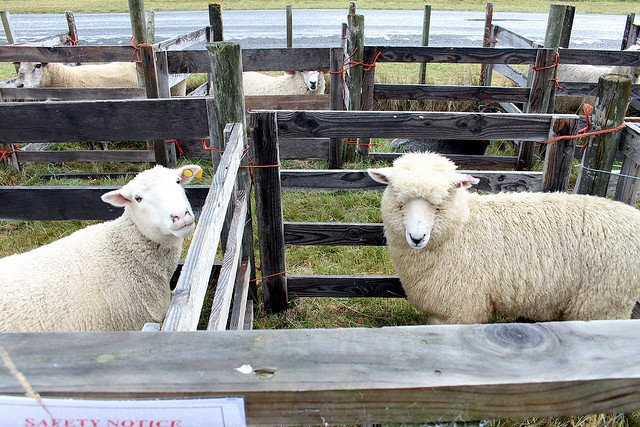Describe the objects in this image and their specific colors. I can see sheep in darkgray, ivory, lightgray, and gray tones, sheep in darkgray, white, and lightgray tones, sheep in darkgray, ivory, and tan tones, sheep in darkgray and lightgray tones, and sheep in darkgray, black, and gray tones in this image. 